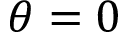<formula> <loc_0><loc_0><loc_500><loc_500>\theta = 0</formula> 